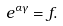Convert formula to latex. <formula><loc_0><loc_0><loc_500><loc_500>e ^ { \alpha \gamma } = f .</formula> 